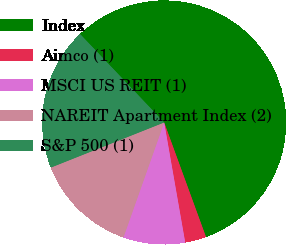Convert chart. <chart><loc_0><loc_0><loc_500><loc_500><pie_chart><fcel>Index<fcel>Aimco (1)<fcel>MSCI US REIT (1)<fcel>NAREIT Apartment Index (2)<fcel>S&P 500 (1)<nl><fcel>56.53%<fcel>2.81%<fcel>8.18%<fcel>13.55%<fcel>18.93%<nl></chart> 